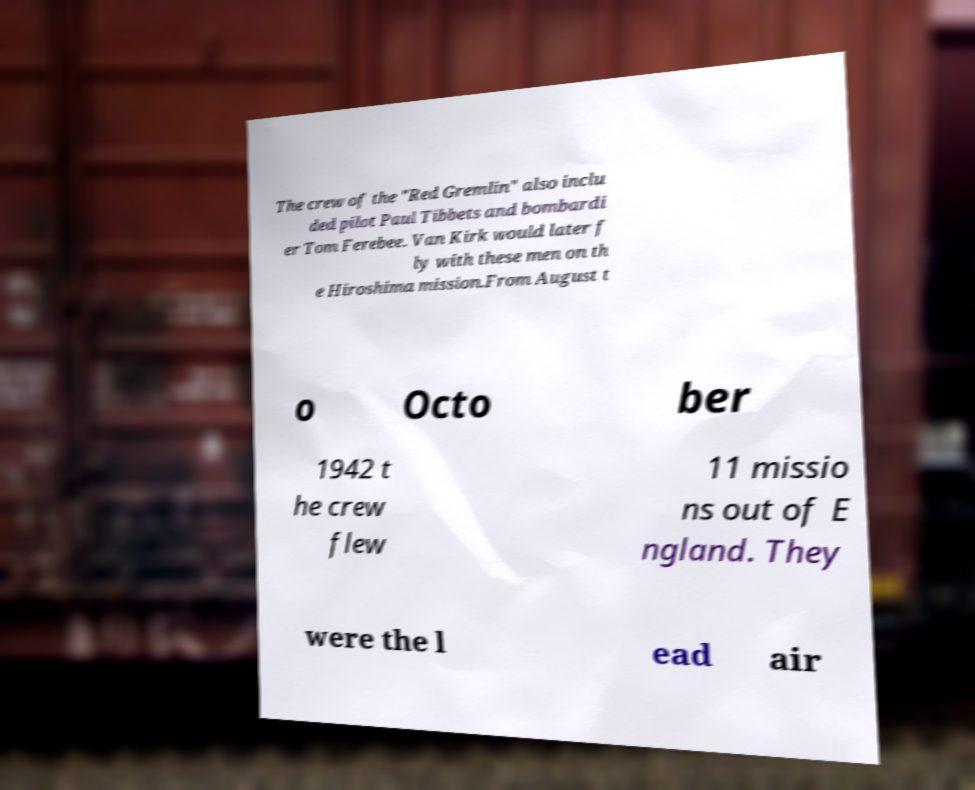I need the written content from this picture converted into text. Can you do that? The crew of the "Red Gremlin" also inclu ded pilot Paul Tibbets and bombardi er Tom Ferebee. Van Kirk would later f ly with these men on th e Hiroshima mission.From August t o Octo ber 1942 t he crew flew 11 missio ns out of E ngland. They were the l ead air 